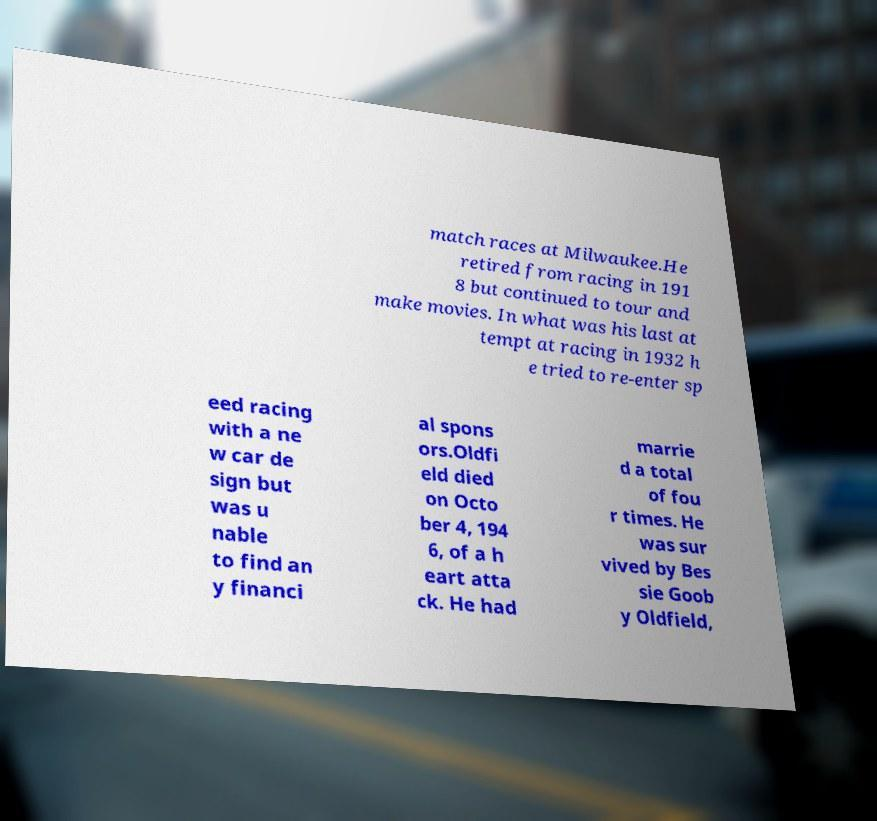There's text embedded in this image that I need extracted. Can you transcribe it verbatim? match races at Milwaukee.He retired from racing in 191 8 but continued to tour and make movies. In what was his last at tempt at racing in 1932 h e tried to re-enter sp eed racing with a ne w car de sign but was u nable to find an y financi al spons ors.Oldfi eld died on Octo ber 4, 194 6, of a h eart atta ck. He had marrie d a total of fou r times. He was sur vived by Bes sie Goob y Oldfield, 